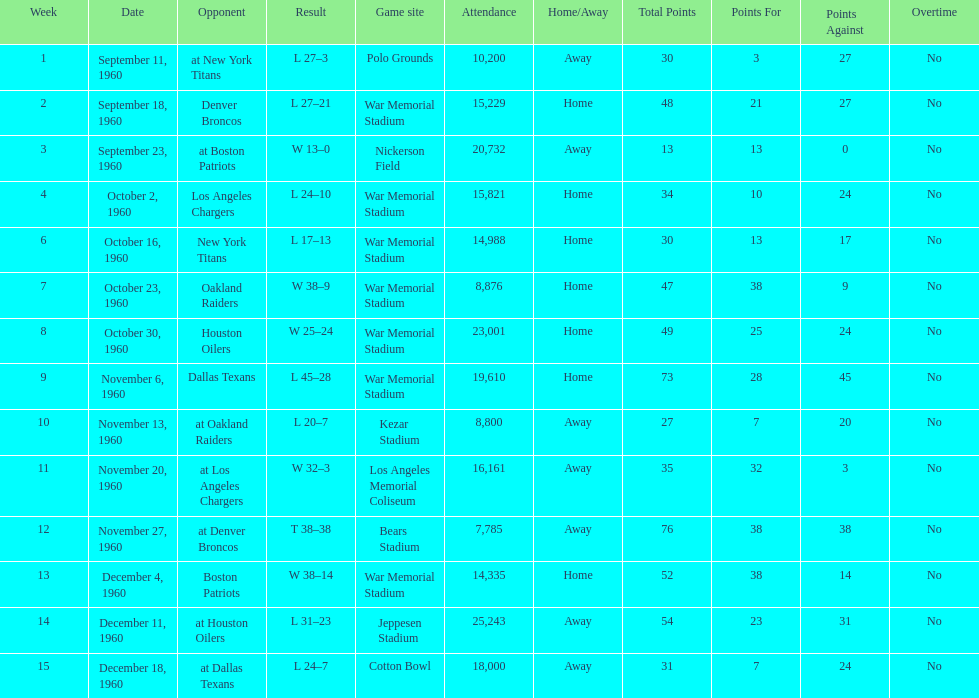Who was the only opponent they played which resulted in a tie game? Denver Broncos. 